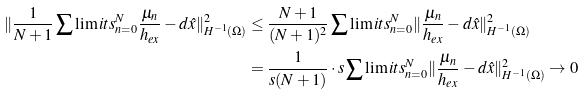Convert formula to latex. <formula><loc_0><loc_0><loc_500><loc_500>\| \frac { 1 } { N + 1 } \sum \lim i t s _ { n = 0 } ^ { N } \frac { \mu _ { n } } { h _ { e x } } - d \hat { x } \| _ { H ^ { - 1 } ( \Omega ) } ^ { 2 } & \leq \frac { N + 1 } { ( N + 1 ) ^ { 2 } } \sum \lim i t s _ { n = 0 } ^ { N } \| \frac { \mu _ { n } } { h _ { e x } } - d \hat { x } \| _ { H ^ { - 1 } ( \Omega ) } ^ { 2 } \\ & = \frac { 1 } { s ( N + 1 ) } \cdot s \sum \lim i t s _ { n = 0 } ^ { N } \| \frac { \mu _ { n } } { h _ { e x } } - d \hat { x } \| _ { H ^ { - 1 } ( \Omega ) } ^ { 2 } \rightarrow 0</formula> 